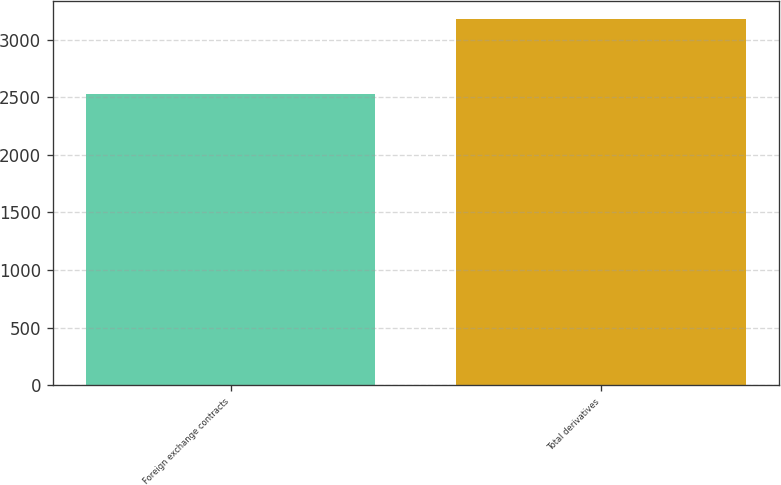Convert chart to OTSL. <chart><loc_0><loc_0><loc_500><loc_500><bar_chart><fcel>Foreign exchange contracts<fcel>Total derivatives<nl><fcel>2524<fcel>3177<nl></chart> 